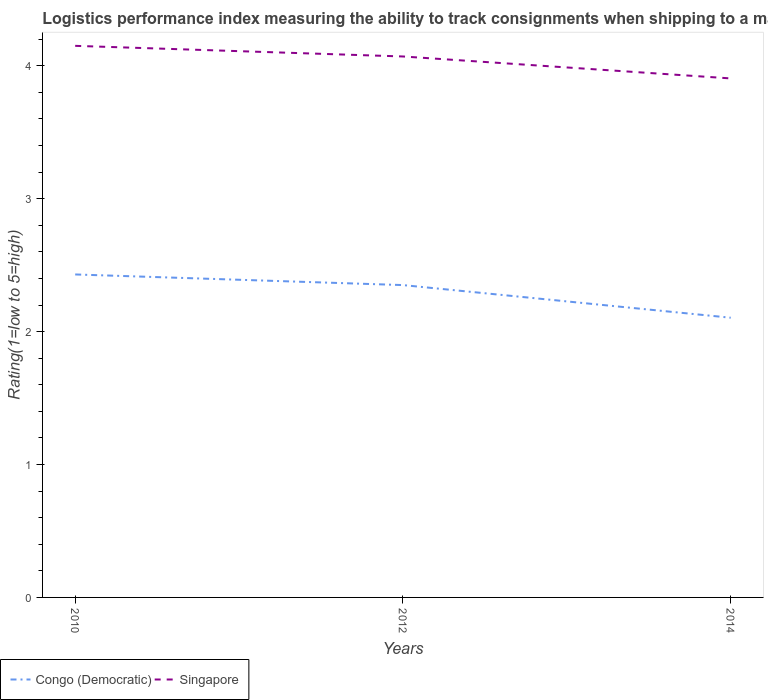How many different coloured lines are there?
Your response must be concise. 2. Across all years, what is the maximum Logistic performance index in Congo (Democratic)?
Your answer should be very brief. 2.1. What is the total Logistic performance index in Congo (Democratic) in the graph?
Your response must be concise. 0.33. What is the difference between the highest and the second highest Logistic performance index in Singapore?
Provide a short and direct response. 0.25. What is the difference between the highest and the lowest Logistic performance index in Singapore?
Your response must be concise. 2. How many lines are there?
Ensure brevity in your answer.  2. Are the values on the major ticks of Y-axis written in scientific E-notation?
Ensure brevity in your answer.  No. Does the graph contain any zero values?
Ensure brevity in your answer.  No. What is the title of the graph?
Offer a terse response. Logistics performance index measuring the ability to track consignments when shipping to a market. Does "Ecuador" appear as one of the legend labels in the graph?
Your response must be concise. No. What is the label or title of the X-axis?
Give a very brief answer. Years. What is the label or title of the Y-axis?
Provide a short and direct response. Rating(1=low to 5=high). What is the Rating(1=low to 5=high) of Congo (Democratic) in 2010?
Provide a short and direct response. 2.43. What is the Rating(1=low to 5=high) of Singapore in 2010?
Your response must be concise. 4.15. What is the Rating(1=low to 5=high) of Congo (Democratic) in 2012?
Offer a very short reply. 2.35. What is the Rating(1=low to 5=high) in Singapore in 2012?
Provide a short and direct response. 4.07. What is the Rating(1=low to 5=high) of Congo (Democratic) in 2014?
Your answer should be very brief. 2.1. What is the Rating(1=low to 5=high) in Singapore in 2014?
Ensure brevity in your answer.  3.9. Across all years, what is the maximum Rating(1=low to 5=high) of Congo (Democratic)?
Your response must be concise. 2.43. Across all years, what is the maximum Rating(1=low to 5=high) of Singapore?
Provide a short and direct response. 4.15. Across all years, what is the minimum Rating(1=low to 5=high) of Congo (Democratic)?
Make the answer very short. 2.1. Across all years, what is the minimum Rating(1=low to 5=high) in Singapore?
Keep it short and to the point. 3.9. What is the total Rating(1=low to 5=high) of Congo (Democratic) in the graph?
Your answer should be very brief. 6.88. What is the total Rating(1=low to 5=high) of Singapore in the graph?
Offer a very short reply. 12.12. What is the difference between the Rating(1=low to 5=high) of Congo (Democratic) in 2010 and that in 2012?
Make the answer very short. 0.08. What is the difference between the Rating(1=low to 5=high) of Congo (Democratic) in 2010 and that in 2014?
Keep it short and to the point. 0.33. What is the difference between the Rating(1=low to 5=high) in Singapore in 2010 and that in 2014?
Give a very brief answer. 0.25. What is the difference between the Rating(1=low to 5=high) in Congo (Democratic) in 2012 and that in 2014?
Your answer should be very brief. 0.25. What is the difference between the Rating(1=low to 5=high) of Singapore in 2012 and that in 2014?
Your response must be concise. 0.17. What is the difference between the Rating(1=low to 5=high) of Congo (Democratic) in 2010 and the Rating(1=low to 5=high) of Singapore in 2012?
Offer a terse response. -1.64. What is the difference between the Rating(1=low to 5=high) in Congo (Democratic) in 2010 and the Rating(1=low to 5=high) in Singapore in 2014?
Provide a succinct answer. -1.47. What is the difference between the Rating(1=low to 5=high) of Congo (Democratic) in 2012 and the Rating(1=low to 5=high) of Singapore in 2014?
Ensure brevity in your answer.  -1.55. What is the average Rating(1=low to 5=high) in Congo (Democratic) per year?
Ensure brevity in your answer.  2.29. What is the average Rating(1=low to 5=high) in Singapore per year?
Your answer should be very brief. 4.04. In the year 2010, what is the difference between the Rating(1=low to 5=high) in Congo (Democratic) and Rating(1=low to 5=high) in Singapore?
Make the answer very short. -1.72. In the year 2012, what is the difference between the Rating(1=low to 5=high) of Congo (Democratic) and Rating(1=low to 5=high) of Singapore?
Provide a short and direct response. -1.72. In the year 2014, what is the difference between the Rating(1=low to 5=high) of Congo (Democratic) and Rating(1=low to 5=high) of Singapore?
Offer a terse response. -1.8. What is the ratio of the Rating(1=low to 5=high) in Congo (Democratic) in 2010 to that in 2012?
Give a very brief answer. 1.03. What is the ratio of the Rating(1=low to 5=high) of Singapore in 2010 to that in 2012?
Your answer should be compact. 1.02. What is the ratio of the Rating(1=low to 5=high) of Congo (Democratic) in 2010 to that in 2014?
Make the answer very short. 1.15. What is the ratio of the Rating(1=low to 5=high) of Singapore in 2010 to that in 2014?
Give a very brief answer. 1.06. What is the ratio of the Rating(1=low to 5=high) of Congo (Democratic) in 2012 to that in 2014?
Provide a short and direct response. 1.12. What is the ratio of the Rating(1=low to 5=high) in Singapore in 2012 to that in 2014?
Your response must be concise. 1.04. What is the difference between the highest and the second highest Rating(1=low to 5=high) in Congo (Democratic)?
Offer a terse response. 0.08. What is the difference between the highest and the lowest Rating(1=low to 5=high) of Congo (Democratic)?
Provide a succinct answer. 0.33. What is the difference between the highest and the lowest Rating(1=low to 5=high) of Singapore?
Keep it short and to the point. 0.25. 